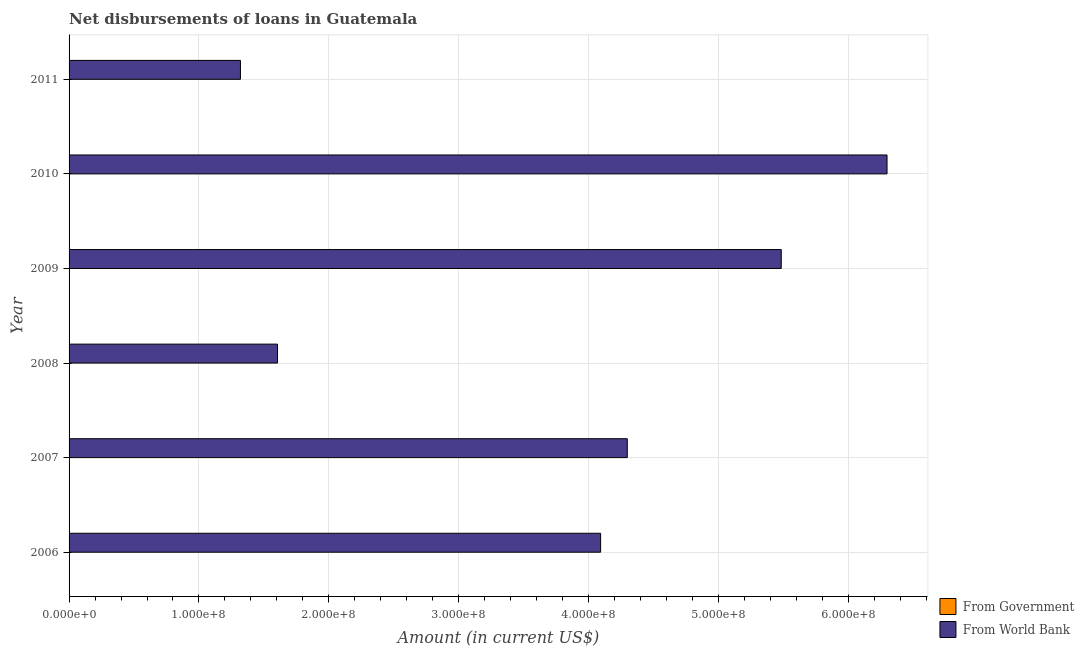How many different coloured bars are there?
Offer a terse response. 1. Are the number of bars per tick equal to the number of legend labels?
Provide a succinct answer. No. How many bars are there on the 1st tick from the bottom?
Keep it short and to the point. 1. In how many cases, is the number of bars for a given year not equal to the number of legend labels?
Provide a short and direct response. 6. Across all years, what is the maximum net disbursements of loan from world bank?
Your response must be concise. 6.30e+08. Across all years, what is the minimum net disbursements of loan from government?
Your response must be concise. 0. What is the difference between the net disbursements of loan from world bank in 2007 and that in 2010?
Give a very brief answer. -2.00e+08. What is the difference between the net disbursements of loan from government in 2011 and the net disbursements of loan from world bank in 2010?
Give a very brief answer. -6.30e+08. What is the average net disbursements of loan from world bank per year?
Ensure brevity in your answer.  3.85e+08. In how many years, is the net disbursements of loan from world bank greater than 540000000 US$?
Your answer should be compact. 2. What is the ratio of the net disbursements of loan from world bank in 2006 to that in 2008?
Your answer should be very brief. 2.55. What is the difference between the highest and the second highest net disbursements of loan from world bank?
Your response must be concise. 8.14e+07. What is the difference between the highest and the lowest net disbursements of loan from world bank?
Ensure brevity in your answer.  4.98e+08. Is the sum of the net disbursements of loan from world bank in 2008 and 2011 greater than the maximum net disbursements of loan from government across all years?
Offer a very short reply. Yes. How many bars are there?
Provide a short and direct response. 6. How many years are there in the graph?
Offer a terse response. 6. What is the difference between two consecutive major ticks on the X-axis?
Make the answer very short. 1.00e+08. Are the values on the major ticks of X-axis written in scientific E-notation?
Provide a succinct answer. Yes. Does the graph contain any zero values?
Offer a very short reply. Yes. Does the graph contain grids?
Keep it short and to the point. Yes. Where does the legend appear in the graph?
Ensure brevity in your answer.  Bottom right. What is the title of the graph?
Give a very brief answer. Net disbursements of loans in Guatemala. Does "From Government" appear as one of the legend labels in the graph?
Offer a terse response. Yes. What is the Amount (in current US$) of From Government in 2006?
Your response must be concise. 0. What is the Amount (in current US$) of From World Bank in 2006?
Give a very brief answer. 4.09e+08. What is the Amount (in current US$) in From World Bank in 2007?
Keep it short and to the point. 4.30e+08. What is the Amount (in current US$) of From Government in 2008?
Ensure brevity in your answer.  0. What is the Amount (in current US$) in From World Bank in 2008?
Provide a succinct answer. 1.60e+08. What is the Amount (in current US$) in From World Bank in 2009?
Provide a succinct answer. 5.48e+08. What is the Amount (in current US$) in From World Bank in 2010?
Your answer should be very brief. 6.30e+08. What is the Amount (in current US$) in From World Bank in 2011?
Offer a very short reply. 1.32e+08. Across all years, what is the maximum Amount (in current US$) of From World Bank?
Keep it short and to the point. 6.30e+08. Across all years, what is the minimum Amount (in current US$) of From World Bank?
Provide a succinct answer. 1.32e+08. What is the total Amount (in current US$) of From Government in the graph?
Provide a succinct answer. 0. What is the total Amount (in current US$) of From World Bank in the graph?
Your answer should be very brief. 2.31e+09. What is the difference between the Amount (in current US$) of From World Bank in 2006 and that in 2007?
Offer a terse response. -2.05e+07. What is the difference between the Amount (in current US$) of From World Bank in 2006 and that in 2008?
Provide a succinct answer. 2.49e+08. What is the difference between the Amount (in current US$) of From World Bank in 2006 and that in 2009?
Offer a very short reply. -1.39e+08. What is the difference between the Amount (in current US$) of From World Bank in 2006 and that in 2010?
Offer a very short reply. -2.20e+08. What is the difference between the Amount (in current US$) of From World Bank in 2006 and that in 2011?
Ensure brevity in your answer.  2.77e+08. What is the difference between the Amount (in current US$) of From World Bank in 2007 and that in 2008?
Offer a terse response. 2.69e+08. What is the difference between the Amount (in current US$) in From World Bank in 2007 and that in 2009?
Your answer should be compact. -1.19e+08. What is the difference between the Amount (in current US$) of From World Bank in 2007 and that in 2010?
Keep it short and to the point. -2.00e+08. What is the difference between the Amount (in current US$) in From World Bank in 2007 and that in 2011?
Provide a succinct answer. 2.98e+08. What is the difference between the Amount (in current US$) in From World Bank in 2008 and that in 2009?
Your answer should be compact. -3.88e+08. What is the difference between the Amount (in current US$) in From World Bank in 2008 and that in 2010?
Your answer should be very brief. -4.69e+08. What is the difference between the Amount (in current US$) of From World Bank in 2008 and that in 2011?
Make the answer very short. 2.85e+07. What is the difference between the Amount (in current US$) of From World Bank in 2009 and that in 2010?
Make the answer very short. -8.14e+07. What is the difference between the Amount (in current US$) in From World Bank in 2009 and that in 2011?
Your response must be concise. 4.16e+08. What is the difference between the Amount (in current US$) in From World Bank in 2010 and that in 2011?
Ensure brevity in your answer.  4.98e+08. What is the average Amount (in current US$) of From Government per year?
Your response must be concise. 0. What is the average Amount (in current US$) of From World Bank per year?
Offer a terse response. 3.85e+08. What is the ratio of the Amount (in current US$) of From World Bank in 2006 to that in 2007?
Your answer should be compact. 0.95. What is the ratio of the Amount (in current US$) in From World Bank in 2006 to that in 2008?
Offer a very short reply. 2.55. What is the ratio of the Amount (in current US$) in From World Bank in 2006 to that in 2009?
Your response must be concise. 0.75. What is the ratio of the Amount (in current US$) of From World Bank in 2006 to that in 2010?
Your response must be concise. 0.65. What is the ratio of the Amount (in current US$) in From World Bank in 2006 to that in 2011?
Your answer should be very brief. 3.1. What is the ratio of the Amount (in current US$) in From World Bank in 2007 to that in 2008?
Your answer should be compact. 2.68. What is the ratio of the Amount (in current US$) in From World Bank in 2007 to that in 2009?
Your answer should be very brief. 0.78. What is the ratio of the Amount (in current US$) of From World Bank in 2007 to that in 2010?
Offer a very short reply. 0.68. What is the ratio of the Amount (in current US$) in From World Bank in 2007 to that in 2011?
Your answer should be compact. 3.26. What is the ratio of the Amount (in current US$) of From World Bank in 2008 to that in 2009?
Give a very brief answer. 0.29. What is the ratio of the Amount (in current US$) of From World Bank in 2008 to that in 2010?
Keep it short and to the point. 0.25. What is the ratio of the Amount (in current US$) of From World Bank in 2008 to that in 2011?
Provide a short and direct response. 1.22. What is the ratio of the Amount (in current US$) in From World Bank in 2009 to that in 2010?
Your answer should be compact. 0.87. What is the ratio of the Amount (in current US$) in From World Bank in 2009 to that in 2011?
Offer a very short reply. 4.16. What is the ratio of the Amount (in current US$) in From World Bank in 2010 to that in 2011?
Your answer should be compact. 4.77. What is the difference between the highest and the second highest Amount (in current US$) in From World Bank?
Provide a succinct answer. 8.14e+07. What is the difference between the highest and the lowest Amount (in current US$) of From World Bank?
Give a very brief answer. 4.98e+08. 